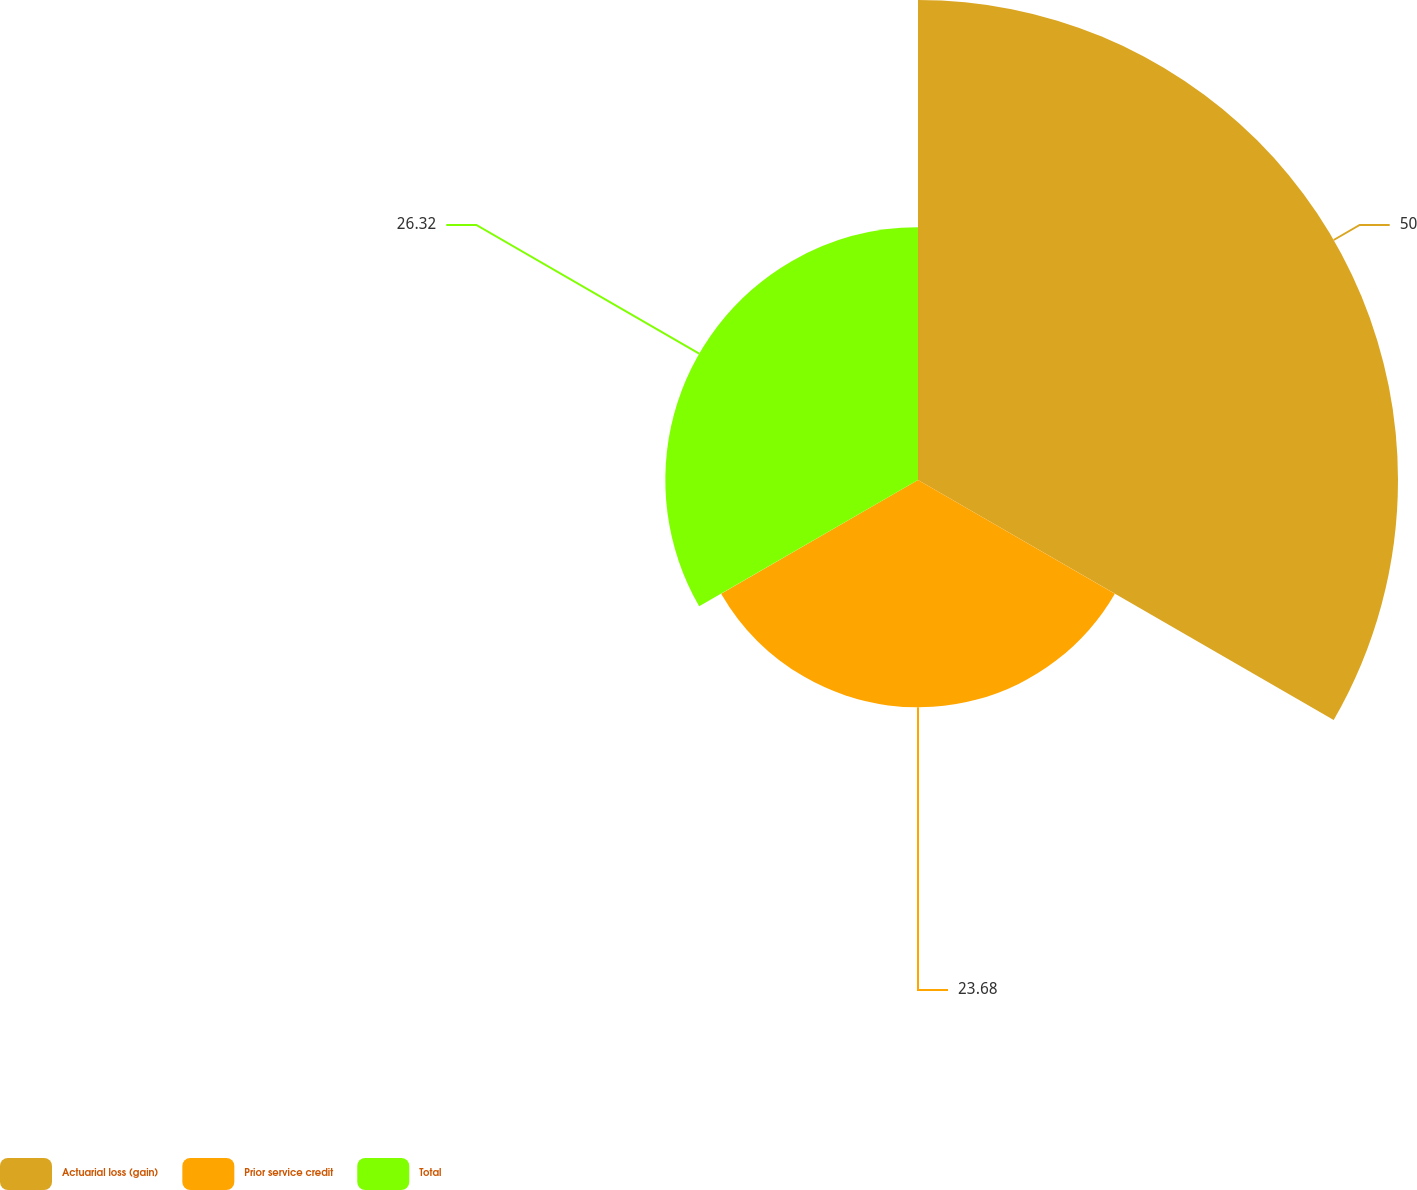Convert chart. <chart><loc_0><loc_0><loc_500><loc_500><pie_chart><fcel>Actuarial loss (gain)<fcel>Prior service credit<fcel>Total<nl><fcel>50.0%<fcel>23.68%<fcel>26.32%<nl></chart> 